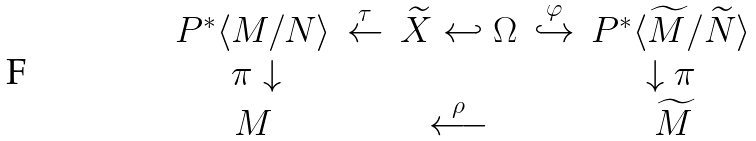Convert formula to latex. <formula><loc_0><loc_0><loc_500><loc_500>\begin{array} { c c c c c } P ^ { * } \langle M / N \rangle & \overset { \tau } { \leftarrow } & \widetilde { X } \hookleftarrow \Omega & \overset { \varphi } { \hookrightarrow } & P ^ { * } \langle \widetilde { M } / \widetilde { N } \rangle \\ \, \pi \downarrow & & & & \downarrow \pi \\ M & & \overset { \rho } { \longleftarrow } & & \, \widetilde { M } \end{array}</formula> 